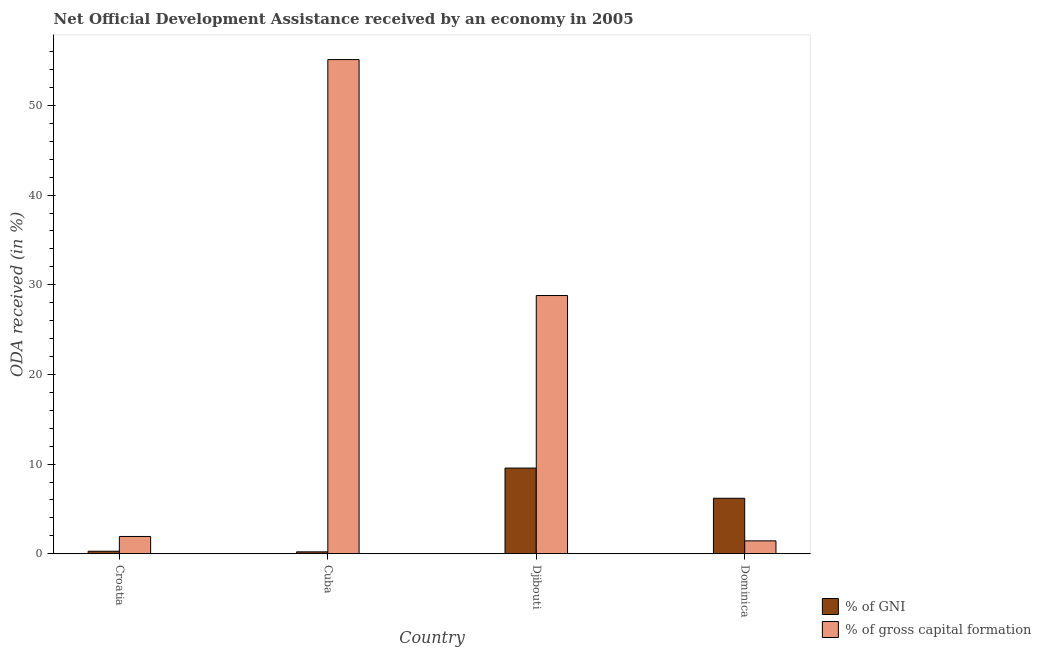How many different coloured bars are there?
Give a very brief answer. 2. Are the number of bars per tick equal to the number of legend labels?
Your answer should be very brief. Yes. What is the label of the 3rd group of bars from the left?
Provide a short and direct response. Djibouti. In how many cases, is the number of bars for a given country not equal to the number of legend labels?
Provide a short and direct response. 0. What is the oda received as percentage of gni in Djibouti?
Make the answer very short. 9.55. Across all countries, what is the maximum oda received as percentage of gross capital formation?
Give a very brief answer. 55.12. Across all countries, what is the minimum oda received as percentage of gni?
Ensure brevity in your answer.  0.21. In which country was the oda received as percentage of gni maximum?
Your answer should be compact. Djibouti. In which country was the oda received as percentage of gross capital formation minimum?
Offer a terse response. Dominica. What is the total oda received as percentage of gross capital formation in the graph?
Your answer should be very brief. 87.28. What is the difference between the oda received as percentage of gross capital formation in Cuba and that in Dominica?
Provide a succinct answer. 53.68. What is the difference between the oda received as percentage of gross capital formation in Croatia and the oda received as percentage of gni in Cuba?
Ensure brevity in your answer.  1.71. What is the average oda received as percentage of gni per country?
Keep it short and to the point. 4.06. What is the difference between the oda received as percentage of gross capital formation and oda received as percentage of gni in Djibouti?
Keep it short and to the point. 19.25. What is the ratio of the oda received as percentage of gross capital formation in Croatia to that in Djibouti?
Offer a very short reply. 0.07. What is the difference between the highest and the second highest oda received as percentage of gni?
Provide a succinct answer. 3.37. What is the difference between the highest and the lowest oda received as percentage of gni?
Your answer should be compact. 9.34. What does the 2nd bar from the left in Dominica represents?
Your answer should be compact. % of gross capital formation. What does the 2nd bar from the right in Djibouti represents?
Your answer should be very brief. % of GNI. How many bars are there?
Provide a short and direct response. 8. How many countries are there in the graph?
Your answer should be very brief. 4. What is the difference between two consecutive major ticks on the Y-axis?
Provide a short and direct response. 10. Are the values on the major ticks of Y-axis written in scientific E-notation?
Offer a terse response. No. Does the graph contain any zero values?
Your answer should be compact. No. Does the graph contain grids?
Offer a terse response. No. How are the legend labels stacked?
Your response must be concise. Vertical. What is the title of the graph?
Offer a terse response. Net Official Development Assistance received by an economy in 2005. Does "Money lenders" appear as one of the legend labels in the graph?
Offer a terse response. No. What is the label or title of the X-axis?
Your response must be concise. Country. What is the label or title of the Y-axis?
Offer a very short reply. ODA received (in %). What is the ODA received (in %) in % of GNI in Croatia?
Keep it short and to the point. 0.28. What is the ODA received (in %) in % of gross capital formation in Croatia?
Give a very brief answer. 1.92. What is the ODA received (in %) in % of GNI in Cuba?
Make the answer very short. 0.21. What is the ODA received (in %) of % of gross capital formation in Cuba?
Your response must be concise. 55.12. What is the ODA received (in %) in % of GNI in Djibouti?
Keep it short and to the point. 9.55. What is the ODA received (in %) in % of gross capital formation in Djibouti?
Make the answer very short. 28.8. What is the ODA received (in %) in % of GNI in Dominica?
Your answer should be very brief. 6.18. What is the ODA received (in %) of % of gross capital formation in Dominica?
Offer a terse response. 1.44. Across all countries, what is the maximum ODA received (in %) in % of GNI?
Your answer should be compact. 9.55. Across all countries, what is the maximum ODA received (in %) of % of gross capital formation?
Provide a succinct answer. 55.12. Across all countries, what is the minimum ODA received (in %) in % of GNI?
Your answer should be very brief. 0.21. Across all countries, what is the minimum ODA received (in %) of % of gross capital formation?
Offer a very short reply. 1.44. What is the total ODA received (in %) in % of GNI in the graph?
Make the answer very short. 16.23. What is the total ODA received (in %) in % of gross capital formation in the graph?
Your response must be concise. 87.28. What is the difference between the ODA received (in %) in % of GNI in Croatia and that in Cuba?
Keep it short and to the point. 0.07. What is the difference between the ODA received (in %) of % of gross capital formation in Croatia and that in Cuba?
Provide a short and direct response. -53.19. What is the difference between the ODA received (in %) in % of GNI in Croatia and that in Djibouti?
Offer a very short reply. -9.28. What is the difference between the ODA received (in %) of % of gross capital formation in Croatia and that in Djibouti?
Offer a terse response. -26.88. What is the difference between the ODA received (in %) of % of GNI in Croatia and that in Dominica?
Provide a short and direct response. -5.91. What is the difference between the ODA received (in %) in % of gross capital formation in Croatia and that in Dominica?
Offer a very short reply. 0.49. What is the difference between the ODA received (in %) in % of GNI in Cuba and that in Djibouti?
Make the answer very short. -9.34. What is the difference between the ODA received (in %) in % of gross capital formation in Cuba and that in Djibouti?
Make the answer very short. 26.32. What is the difference between the ODA received (in %) in % of GNI in Cuba and that in Dominica?
Your answer should be very brief. -5.97. What is the difference between the ODA received (in %) of % of gross capital formation in Cuba and that in Dominica?
Make the answer very short. 53.68. What is the difference between the ODA received (in %) in % of GNI in Djibouti and that in Dominica?
Give a very brief answer. 3.37. What is the difference between the ODA received (in %) of % of gross capital formation in Djibouti and that in Dominica?
Provide a short and direct response. 27.36. What is the difference between the ODA received (in %) of % of GNI in Croatia and the ODA received (in %) of % of gross capital formation in Cuba?
Offer a very short reply. -54.84. What is the difference between the ODA received (in %) of % of GNI in Croatia and the ODA received (in %) of % of gross capital formation in Djibouti?
Offer a very short reply. -28.52. What is the difference between the ODA received (in %) of % of GNI in Croatia and the ODA received (in %) of % of gross capital formation in Dominica?
Provide a succinct answer. -1.16. What is the difference between the ODA received (in %) of % of GNI in Cuba and the ODA received (in %) of % of gross capital formation in Djibouti?
Your answer should be very brief. -28.59. What is the difference between the ODA received (in %) of % of GNI in Cuba and the ODA received (in %) of % of gross capital formation in Dominica?
Offer a very short reply. -1.23. What is the difference between the ODA received (in %) in % of GNI in Djibouti and the ODA received (in %) in % of gross capital formation in Dominica?
Keep it short and to the point. 8.12. What is the average ODA received (in %) in % of GNI per country?
Give a very brief answer. 4.06. What is the average ODA received (in %) in % of gross capital formation per country?
Ensure brevity in your answer.  21.82. What is the difference between the ODA received (in %) in % of GNI and ODA received (in %) in % of gross capital formation in Croatia?
Ensure brevity in your answer.  -1.65. What is the difference between the ODA received (in %) in % of GNI and ODA received (in %) in % of gross capital formation in Cuba?
Your response must be concise. -54.91. What is the difference between the ODA received (in %) in % of GNI and ODA received (in %) in % of gross capital formation in Djibouti?
Keep it short and to the point. -19.25. What is the difference between the ODA received (in %) in % of GNI and ODA received (in %) in % of gross capital formation in Dominica?
Provide a short and direct response. 4.75. What is the ratio of the ODA received (in %) in % of GNI in Croatia to that in Cuba?
Offer a very short reply. 1.32. What is the ratio of the ODA received (in %) in % of gross capital formation in Croatia to that in Cuba?
Provide a short and direct response. 0.03. What is the ratio of the ODA received (in %) in % of GNI in Croatia to that in Djibouti?
Make the answer very short. 0.03. What is the ratio of the ODA received (in %) in % of gross capital formation in Croatia to that in Djibouti?
Provide a short and direct response. 0.07. What is the ratio of the ODA received (in %) in % of GNI in Croatia to that in Dominica?
Your answer should be compact. 0.04. What is the ratio of the ODA received (in %) in % of gross capital formation in Croatia to that in Dominica?
Ensure brevity in your answer.  1.34. What is the ratio of the ODA received (in %) of % of GNI in Cuba to that in Djibouti?
Offer a terse response. 0.02. What is the ratio of the ODA received (in %) of % of gross capital formation in Cuba to that in Djibouti?
Provide a succinct answer. 1.91. What is the ratio of the ODA received (in %) of % of GNI in Cuba to that in Dominica?
Give a very brief answer. 0.03. What is the ratio of the ODA received (in %) of % of gross capital formation in Cuba to that in Dominica?
Offer a very short reply. 38.37. What is the ratio of the ODA received (in %) of % of GNI in Djibouti to that in Dominica?
Your response must be concise. 1.54. What is the ratio of the ODA received (in %) in % of gross capital formation in Djibouti to that in Dominica?
Your response must be concise. 20.05. What is the difference between the highest and the second highest ODA received (in %) in % of GNI?
Keep it short and to the point. 3.37. What is the difference between the highest and the second highest ODA received (in %) in % of gross capital formation?
Offer a terse response. 26.32. What is the difference between the highest and the lowest ODA received (in %) of % of GNI?
Provide a succinct answer. 9.34. What is the difference between the highest and the lowest ODA received (in %) of % of gross capital formation?
Your answer should be very brief. 53.68. 